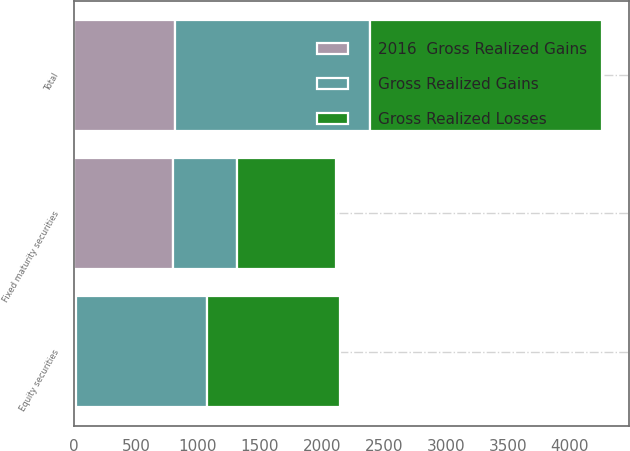<chart> <loc_0><loc_0><loc_500><loc_500><stacked_bar_chart><ecel><fcel>Fixed maturity securities<fcel>Equity securities<fcel>Total<nl><fcel>Gross Realized Losses<fcel>801<fcel>1072<fcel>1873<nl><fcel>2016  Gross Realized Gains<fcel>800<fcel>15<fcel>815<nl><fcel>Gross Realized Gains<fcel>517<fcel>1060<fcel>1577<nl></chart> 